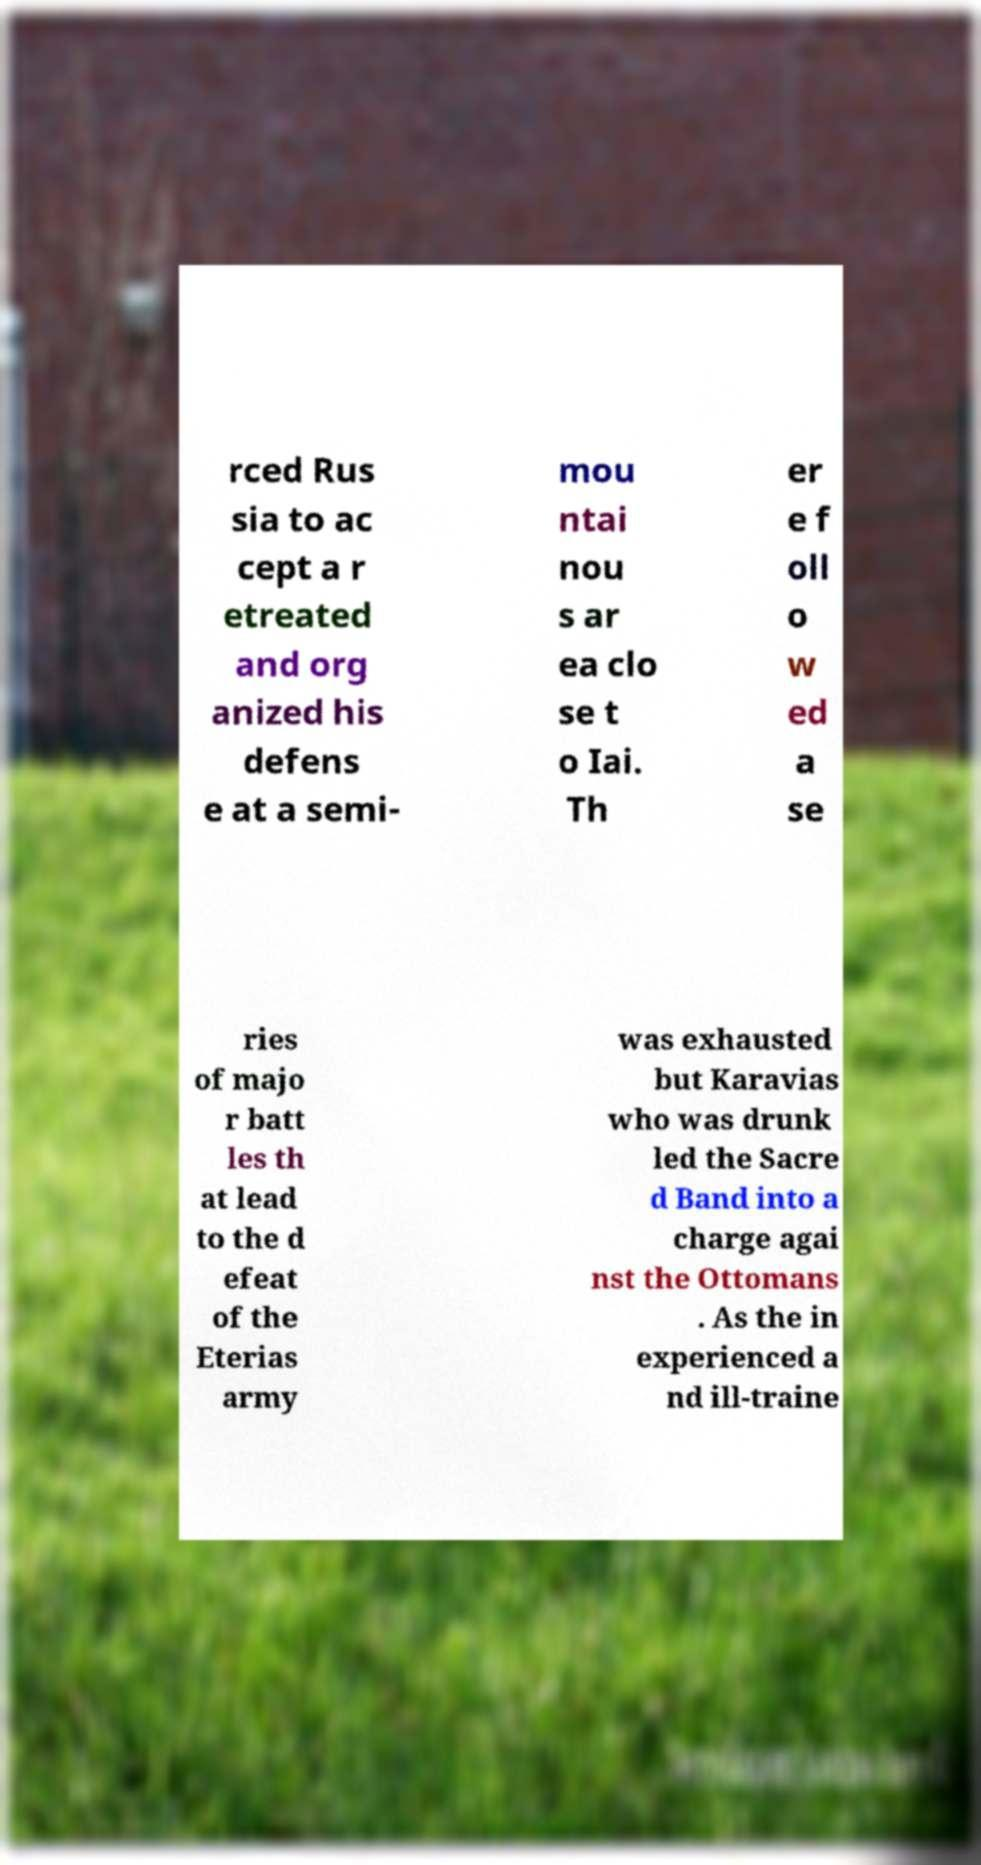Please identify and transcribe the text found in this image. rced Rus sia to ac cept a r etreated and org anized his defens e at a semi- mou ntai nou s ar ea clo se t o Iai. Th er e f oll o w ed a se ries of majo r batt les th at lead to the d efeat of the Eterias army was exhausted but Karavias who was drunk led the Sacre d Band into a charge agai nst the Ottomans . As the in experienced a nd ill-traine 